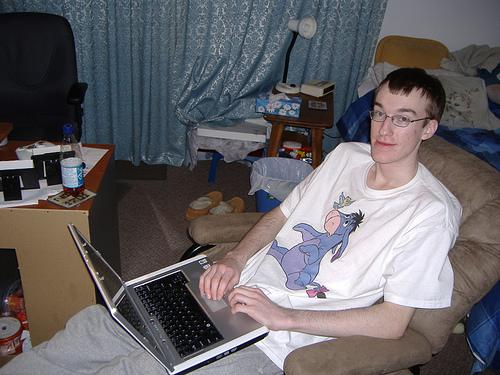What is the can to his side primarily used for? Please explain your reasoning. trash. There is a trash can to the left of the man in the armchair. 